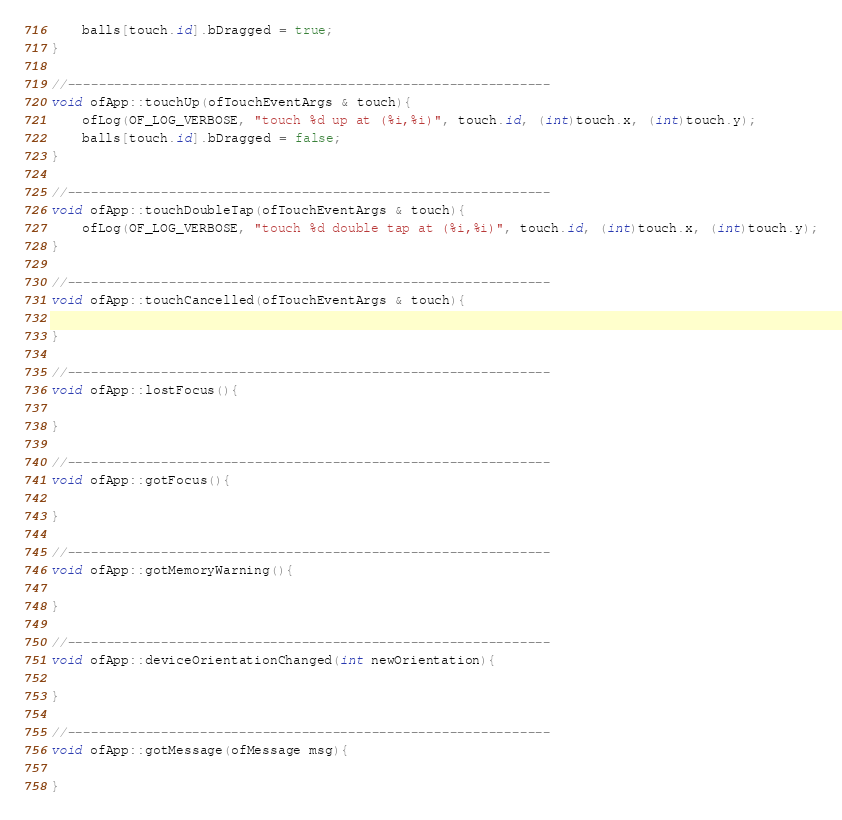<code> <loc_0><loc_0><loc_500><loc_500><_ObjectiveC_>	balls[touch.id].bDragged = true;	
}

//--------------------------------------------------------------
void ofApp::touchUp(ofTouchEventArgs & touch){
    ofLog(OF_LOG_VERBOSE, "touch %d up at (%i,%i)", touch.id, (int)touch.x, (int)touch.y);
	balls[touch.id].bDragged = false;
}

//--------------------------------------------------------------
void ofApp::touchDoubleTap(ofTouchEventArgs & touch){
    ofLog(OF_LOG_VERBOSE, "touch %d double tap at (%i,%i)", touch.id, (int)touch.x, (int)touch.y);
}

//--------------------------------------------------------------
void ofApp::touchCancelled(ofTouchEventArgs & touch){
    
}

//--------------------------------------------------------------
void ofApp::lostFocus(){
    
}

//--------------------------------------------------------------
void ofApp::gotFocus(){
    
}

//--------------------------------------------------------------
void ofApp::gotMemoryWarning(){
    
}

//--------------------------------------------------------------
void ofApp::deviceOrientationChanged(int newOrientation){
    
}

//--------------------------------------------------------------
void ofApp::gotMessage(ofMessage msg){
	
}

</code> 